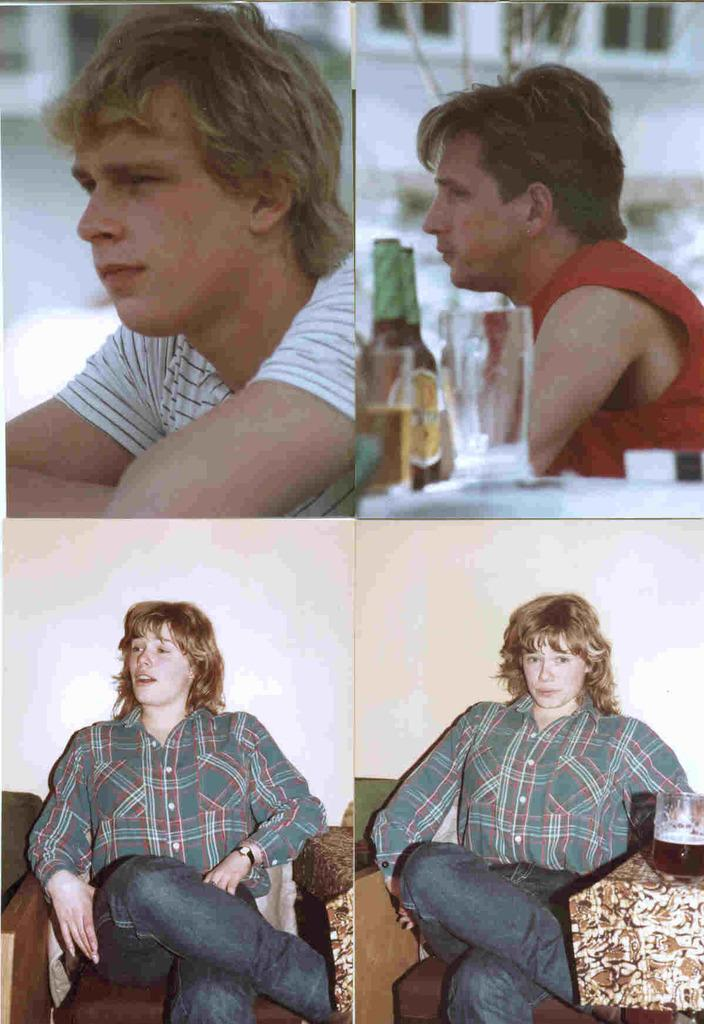What are the people in the image doing? The people in the image are sitting. What objects can be seen in the image that are typically used for drinking? There are glasses in the image. What other objects can be seen in the image that are typically used for holding liquids? There are bottles in the image. How many geese are present in the image? There are no geese present in the image. What type of books can be seen on the table in the image? There is no table or books present in the image. 